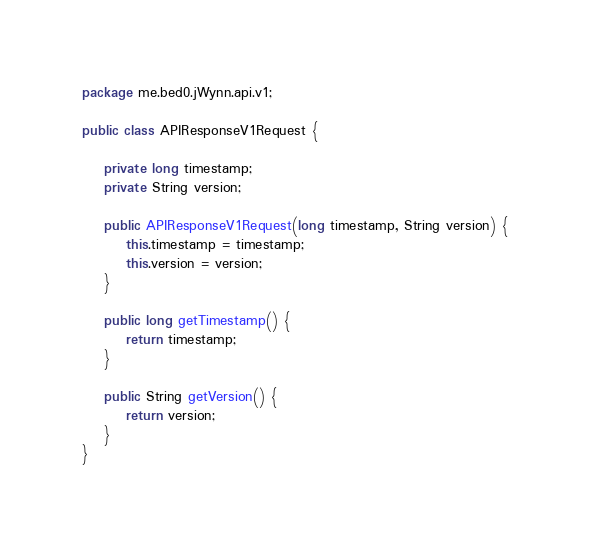Convert code to text. <code><loc_0><loc_0><loc_500><loc_500><_Java_>package me.bed0.jWynn.api.v1;

public class APIResponseV1Request {

    private long timestamp;
    private String version;

    public APIResponseV1Request(long timestamp, String version) {
        this.timestamp = timestamp;
        this.version = version;
    }

    public long getTimestamp() {
        return timestamp;
    }

    public String getVersion() {
        return version;
    }
}
</code> 